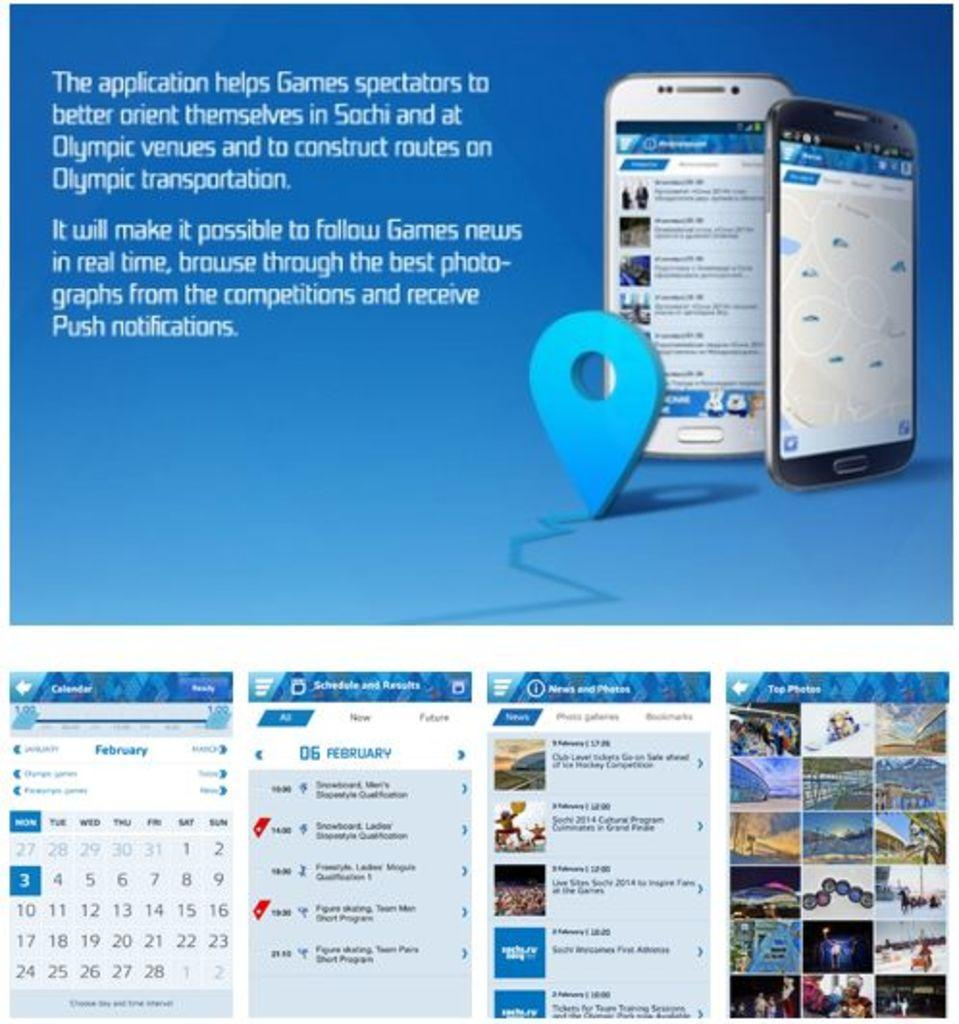<image>
Create a compact narrative representing the image presented. Advertisement about an app to help spectators navigate in Sochi during the Olympics with the month of February on the bottom left. 